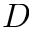<formula> <loc_0><loc_0><loc_500><loc_500>D</formula> 